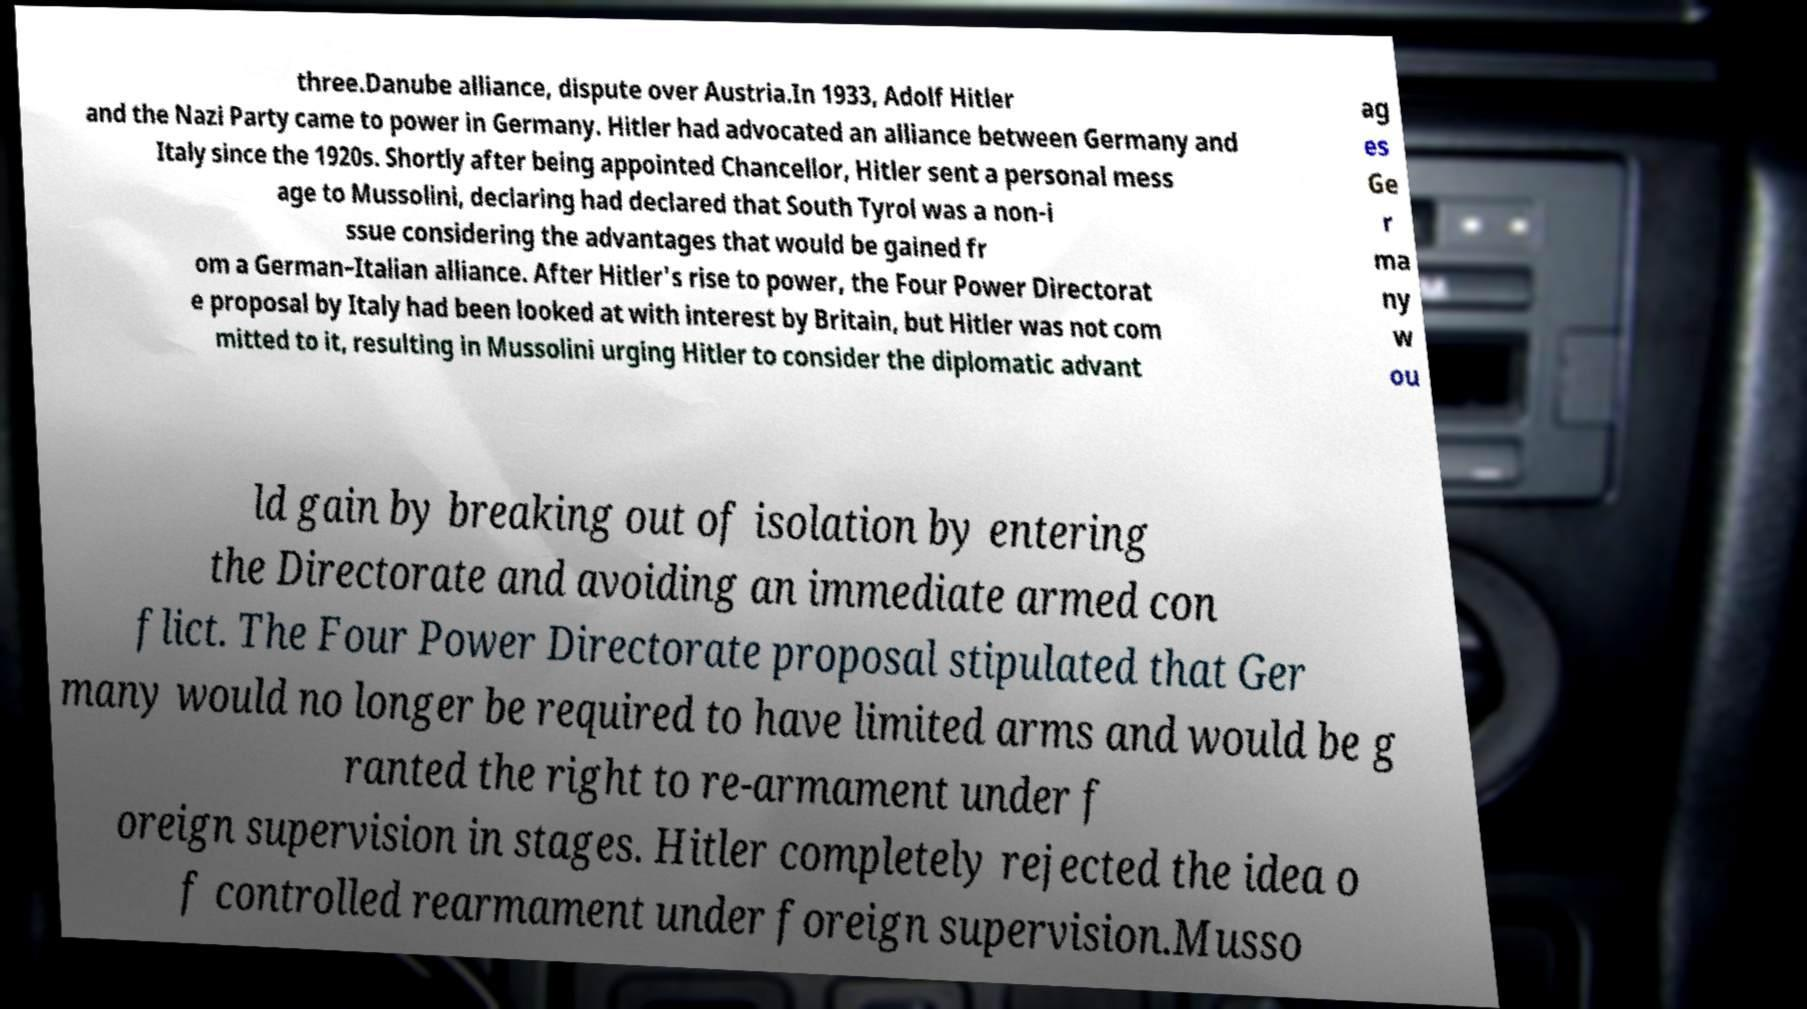There's text embedded in this image that I need extracted. Can you transcribe it verbatim? three.Danube alliance, dispute over Austria.In 1933, Adolf Hitler and the Nazi Party came to power in Germany. Hitler had advocated an alliance between Germany and Italy since the 1920s. Shortly after being appointed Chancellor, Hitler sent a personal mess age to Mussolini, declaring had declared that South Tyrol was a non-i ssue considering the advantages that would be gained fr om a German–Italian alliance. After Hitler's rise to power, the Four Power Directorat e proposal by Italy had been looked at with interest by Britain, but Hitler was not com mitted to it, resulting in Mussolini urging Hitler to consider the diplomatic advant ag es Ge r ma ny w ou ld gain by breaking out of isolation by entering the Directorate and avoiding an immediate armed con flict. The Four Power Directorate proposal stipulated that Ger many would no longer be required to have limited arms and would be g ranted the right to re-armament under f oreign supervision in stages. Hitler completely rejected the idea o f controlled rearmament under foreign supervision.Musso 